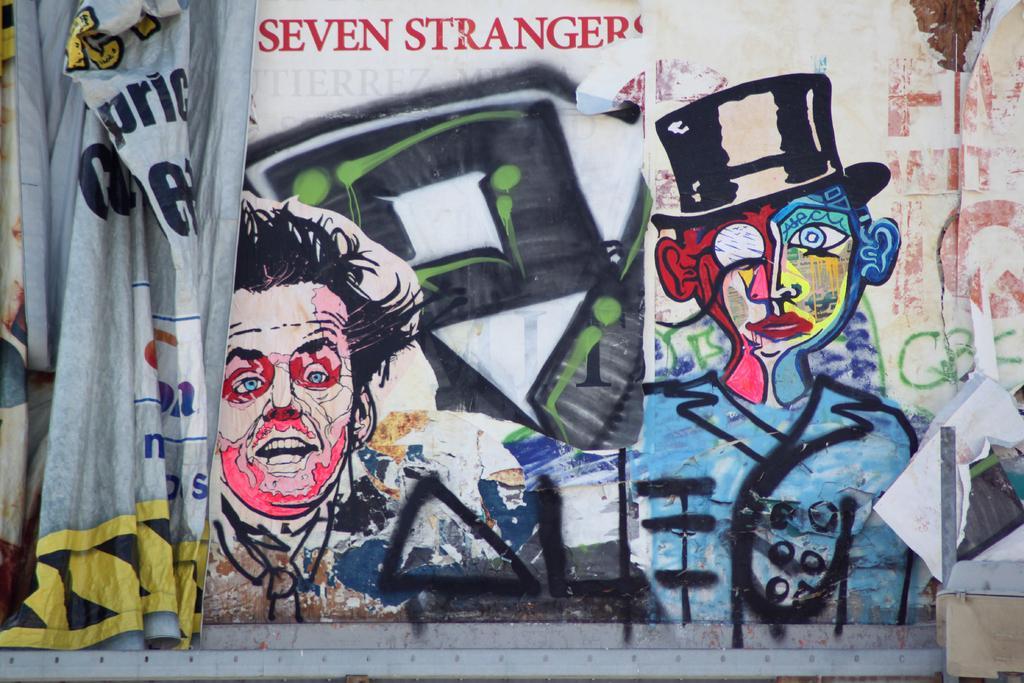Please provide a concise description of this image. In this image we can see one big wall painted with colorful images and some text. There is one big banner with some text on it and some objects are on the surface. 